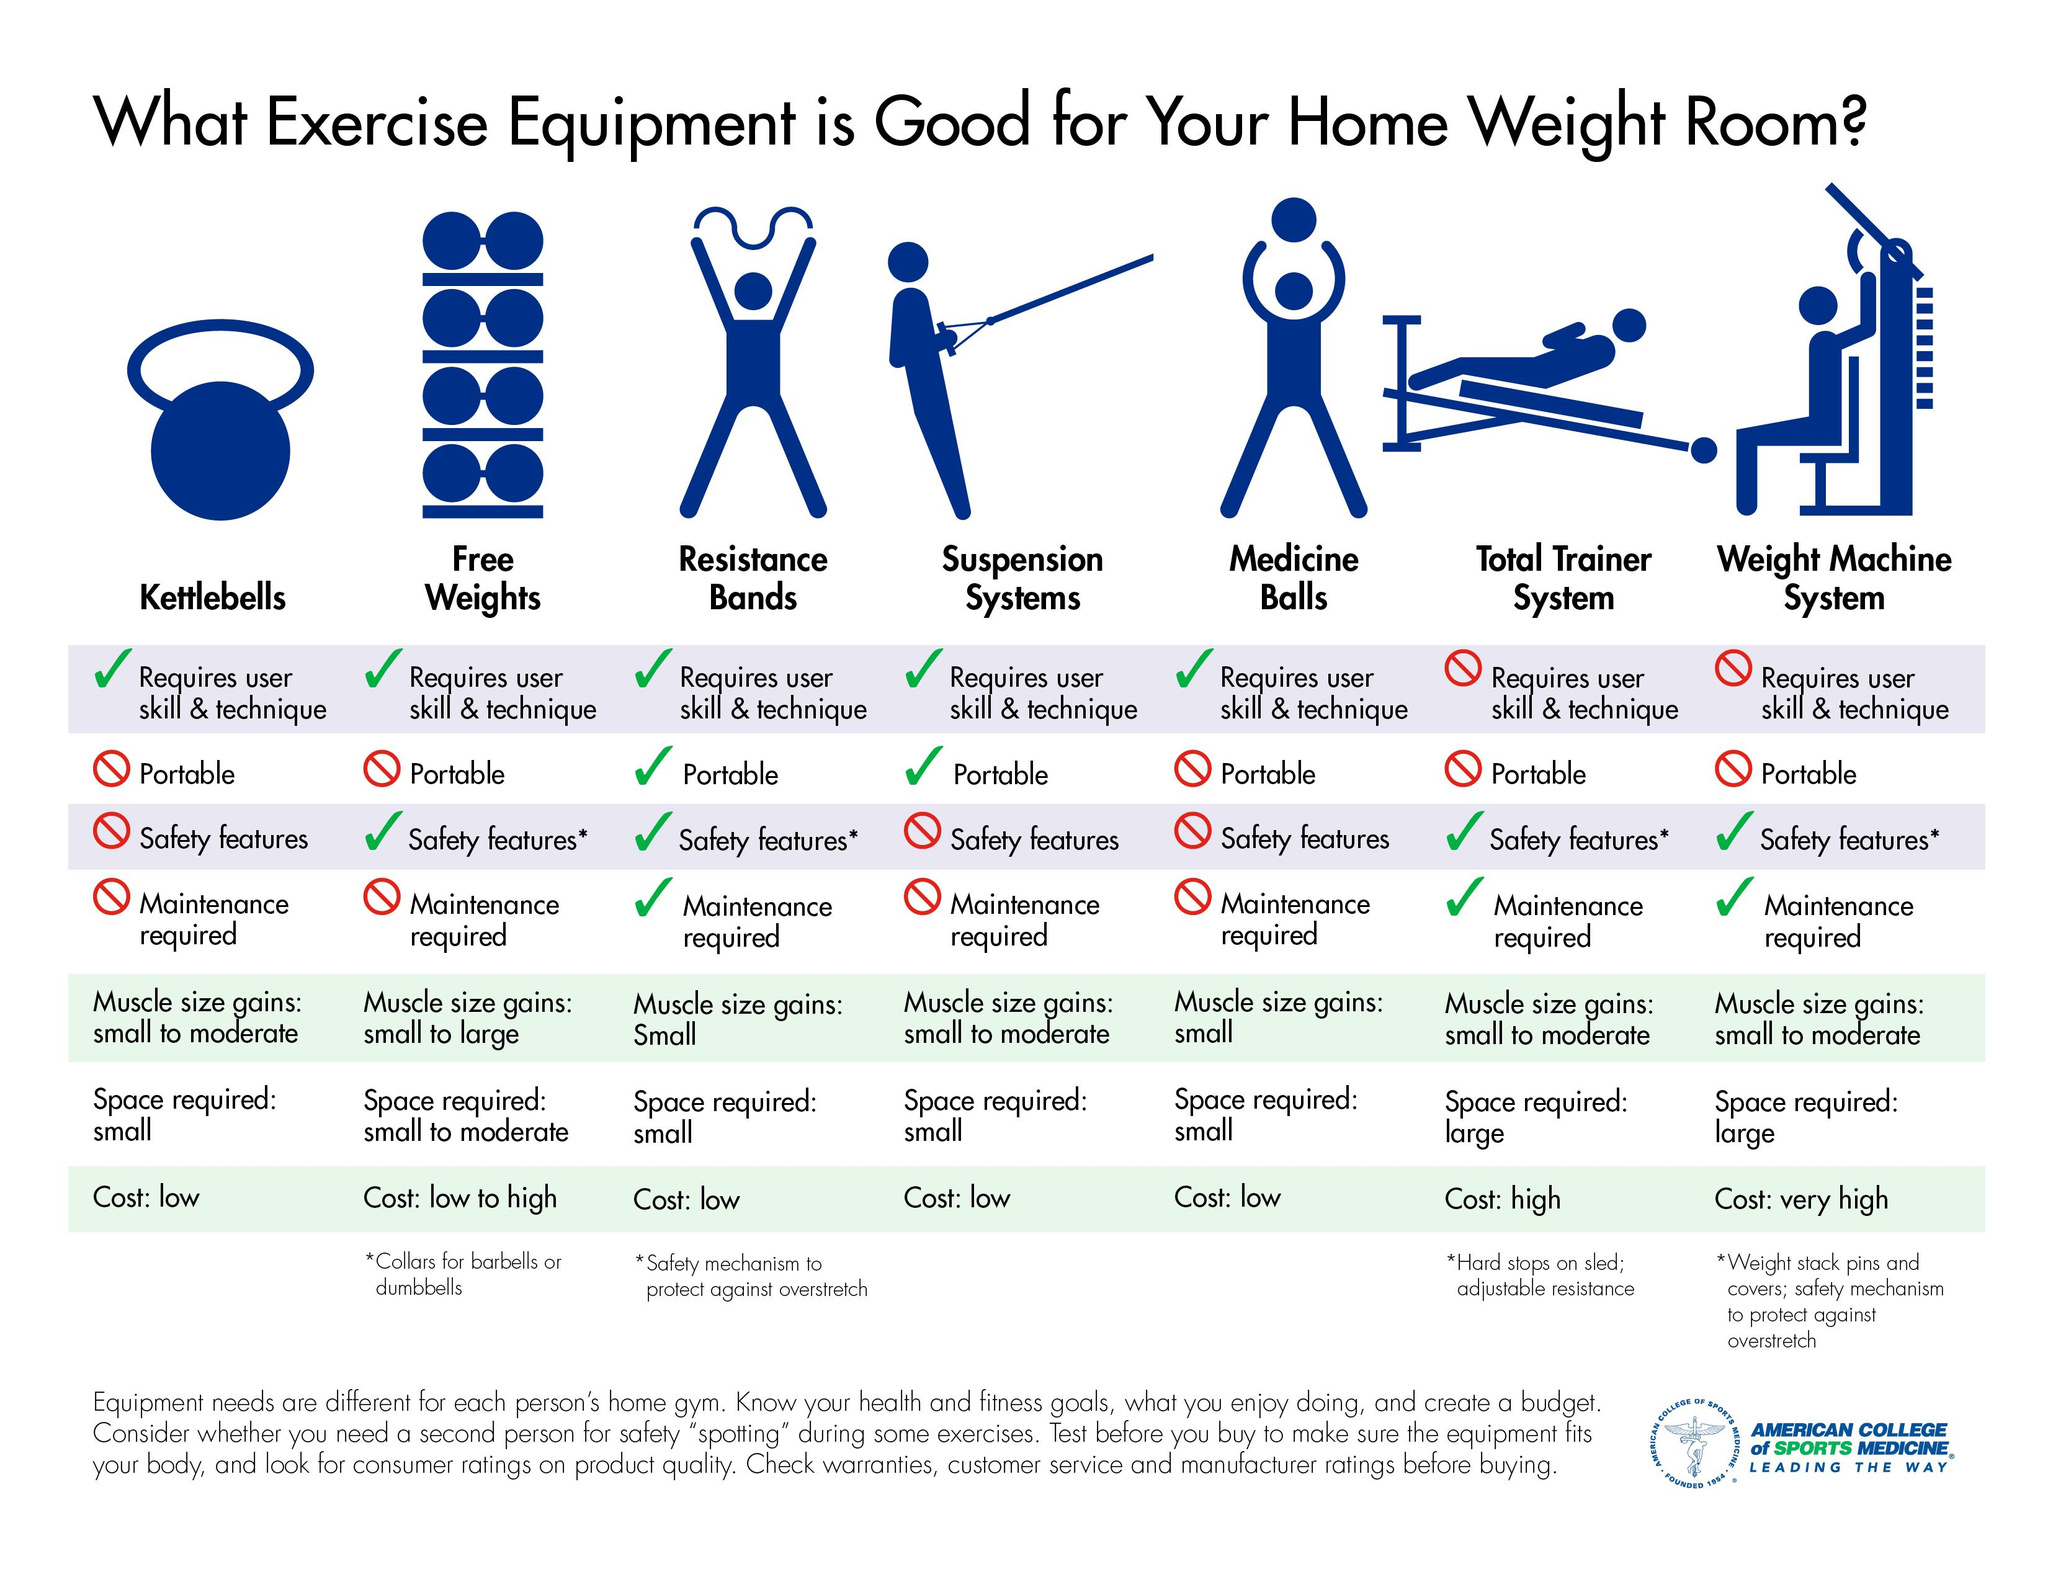Give some essential details in this illustration. The Total Trainer System and the Weight Machine System are exercise equipment that require maintenance, in addition to the resistance bands. The home weight room equipment that do not require user skill and technique are the Total Trainer System and the Weight Machine System. Two portable exercise equipment options that are suitable for a home weight room are resistance bands and suspension systems. 